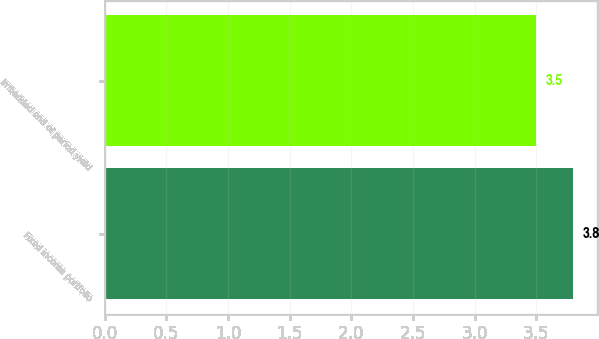<chart> <loc_0><loc_0><loc_500><loc_500><bar_chart><fcel>Fixed income portfolio<fcel>Imbedded end of period yield<nl><fcel>3.8<fcel>3.5<nl></chart> 